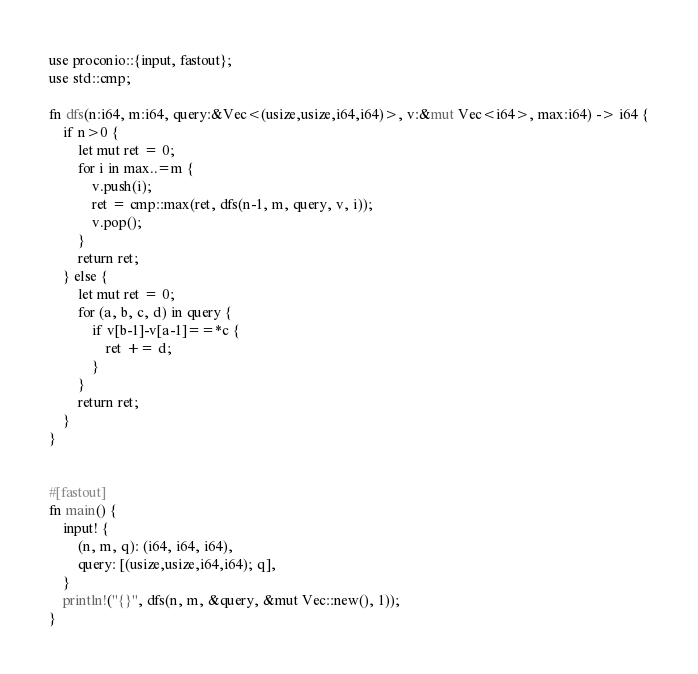<code> <loc_0><loc_0><loc_500><loc_500><_Rust_>use proconio::{input, fastout};
use std::cmp;

fn dfs(n:i64, m:i64, query:&Vec<(usize,usize,i64,i64)>, v:&mut Vec<i64>, max:i64) -> i64 {
    if n>0 {
        let mut ret = 0;
        for i in max..=m {
            v.push(i);
            ret = cmp::max(ret, dfs(n-1, m, query, v, i));
            v.pop();
        }
        return ret;
    } else {
        let mut ret = 0;
        for (a, b, c, d) in query {
            if v[b-1]-v[a-1]==*c {
                ret += d;
            }
        }
        return ret;
    }
}
    

#[fastout]
fn main() {
    input! {
        (n, m, q): (i64, i64, i64),
        query: [(usize,usize,i64,i64); q],
    }
    println!("{}", dfs(n, m, &query, &mut Vec::new(), 1));
}
</code> 